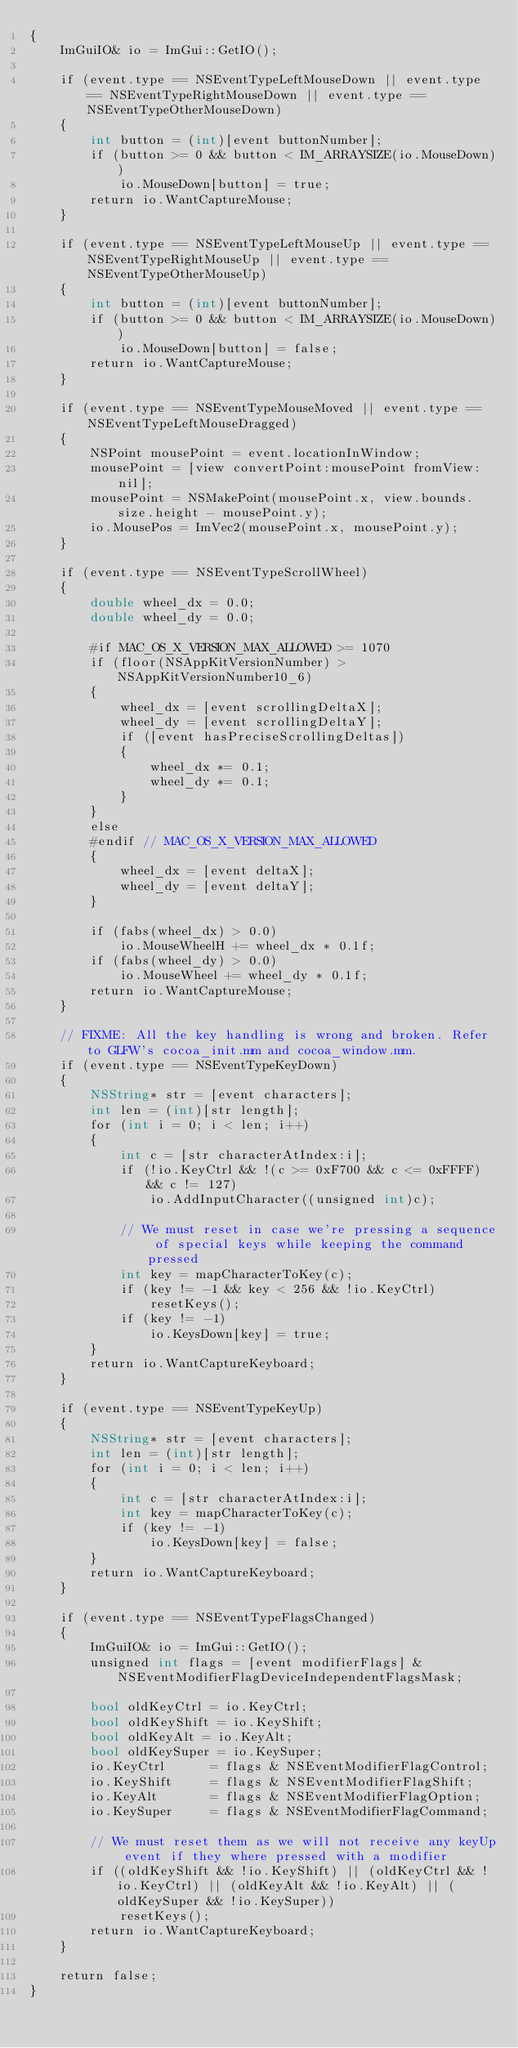Convert code to text. <code><loc_0><loc_0><loc_500><loc_500><_ObjectiveC_>{
    ImGuiIO& io = ImGui::GetIO();

    if (event.type == NSEventTypeLeftMouseDown || event.type == NSEventTypeRightMouseDown || event.type == NSEventTypeOtherMouseDown)
    {
        int button = (int)[event buttonNumber];
        if (button >= 0 && button < IM_ARRAYSIZE(io.MouseDown))
            io.MouseDown[button] = true;
        return io.WantCaptureMouse;
    }

    if (event.type == NSEventTypeLeftMouseUp || event.type == NSEventTypeRightMouseUp || event.type == NSEventTypeOtherMouseUp)
    {
        int button = (int)[event buttonNumber];
        if (button >= 0 && button < IM_ARRAYSIZE(io.MouseDown))
            io.MouseDown[button] = false;
        return io.WantCaptureMouse;
    }

    if (event.type == NSEventTypeMouseMoved || event.type == NSEventTypeLeftMouseDragged)
    {
        NSPoint mousePoint = event.locationInWindow;
        mousePoint = [view convertPoint:mousePoint fromView:nil];
        mousePoint = NSMakePoint(mousePoint.x, view.bounds.size.height - mousePoint.y);
        io.MousePos = ImVec2(mousePoint.x, mousePoint.y);
    }

    if (event.type == NSEventTypeScrollWheel)
    {
        double wheel_dx = 0.0;
        double wheel_dy = 0.0;

        #if MAC_OS_X_VERSION_MAX_ALLOWED >= 1070
        if (floor(NSAppKitVersionNumber) > NSAppKitVersionNumber10_6)
        {
            wheel_dx = [event scrollingDeltaX];
            wheel_dy = [event scrollingDeltaY];
            if ([event hasPreciseScrollingDeltas])
            {
                wheel_dx *= 0.1;
                wheel_dy *= 0.1;
            }
        }
        else
        #endif // MAC_OS_X_VERSION_MAX_ALLOWED
        {
            wheel_dx = [event deltaX];
            wheel_dy = [event deltaY];
        }

        if (fabs(wheel_dx) > 0.0)
            io.MouseWheelH += wheel_dx * 0.1f;
        if (fabs(wheel_dy) > 0.0)
            io.MouseWheel += wheel_dy * 0.1f;
        return io.WantCaptureMouse;
    }

    // FIXME: All the key handling is wrong and broken. Refer to GLFW's cocoa_init.mm and cocoa_window.mm.
    if (event.type == NSEventTypeKeyDown)
    {
        NSString* str = [event characters];
        int len = (int)[str length];
        for (int i = 0; i < len; i++)
        {
            int c = [str characterAtIndex:i];
            if (!io.KeyCtrl && !(c >= 0xF700 && c <= 0xFFFF) && c != 127)
                io.AddInputCharacter((unsigned int)c);

            // We must reset in case we're pressing a sequence of special keys while keeping the command pressed
            int key = mapCharacterToKey(c);
            if (key != -1 && key < 256 && !io.KeyCtrl)
                resetKeys();
            if (key != -1)
                io.KeysDown[key] = true;
        }
        return io.WantCaptureKeyboard;
    }

    if (event.type == NSEventTypeKeyUp)
    {
        NSString* str = [event characters];
        int len = (int)[str length];
        for (int i = 0; i < len; i++)
        {
            int c = [str characterAtIndex:i];
            int key = mapCharacterToKey(c);
            if (key != -1)
                io.KeysDown[key] = false;
        }
        return io.WantCaptureKeyboard;
    }

    if (event.type == NSEventTypeFlagsChanged)
    {
        ImGuiIO& io = ImGui::GetIO();
        unsigned int flags = [event modifierFlags] & NSEventModifierFlagDeviceIndependentFlagsMask;

        bool oldKeyCtrl = io.KeyCtrl;
        bool oldKeyShift = io.KeyShift;
        bool oldKeyAlt = io.KeyAlt;
        bool oldKeySuper = io.KeySuper;
        io.KeyCtrl      = flags & NSEventModifierFlagControl;
        io.KeyShift     = flags & NSEventModifierFlagShift;
        io.KeyAlt       = flags & NSEventModifierFlagOption;
        io.KeySuper     = flags & NSEventModifierFlagCommand;

        // We must reset them as we will not receive any keyUp event if they where pressed with a modifier
        if ((oldKeyShift && !io.KeyShift) || (oldKeyCtrl && !io.KeyCtrl) || (oldKeyAlt && !io.KeyAlt) || (oldKeySuper && !io.KeySuper))
            resetKeys();
        return io.WantCaptureKeyboard;
    }

    return false;
}
</code> 